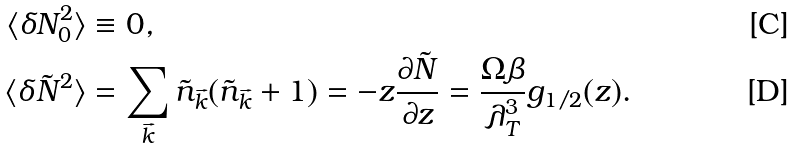Convert formula to latex. <formula><loc_0><loc_0><loc_500><loc_500>\langle \delta N _ { 0 } ^ { 2 } \rangle & \equiv 0 , \\ \langle \delta \tilde { N } ^ { 2 } \rangle & = \sum _ { \vec { k } } \tilde { n } _ { \vec { k } } ( \tilde { n } _ { \vec { k } } + 1 ) = - z \frac { \partial \tilde { N } } { \partial z } = \frac { \Omega \beta } { \lambda _ { T } ^ { 3 } } g _ { 1 / 2 } ( z ) .</formula> 